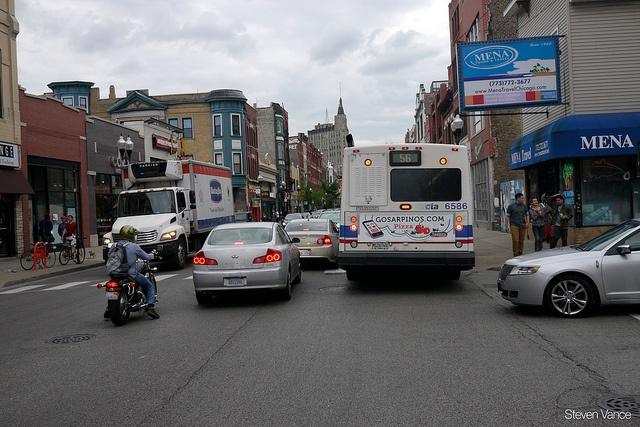Describe the objects in this image and their specific colors. I can see bus in gray, darkgray, black, and navy tones, car in gray, black, darkgray, and lightgray tones, truck in gray, black, darkgray, and lightgray tones, car in gray, darkgray, black, and lightgray tones, and car in gray, darkgray, black, and lightgray tones in this image. 